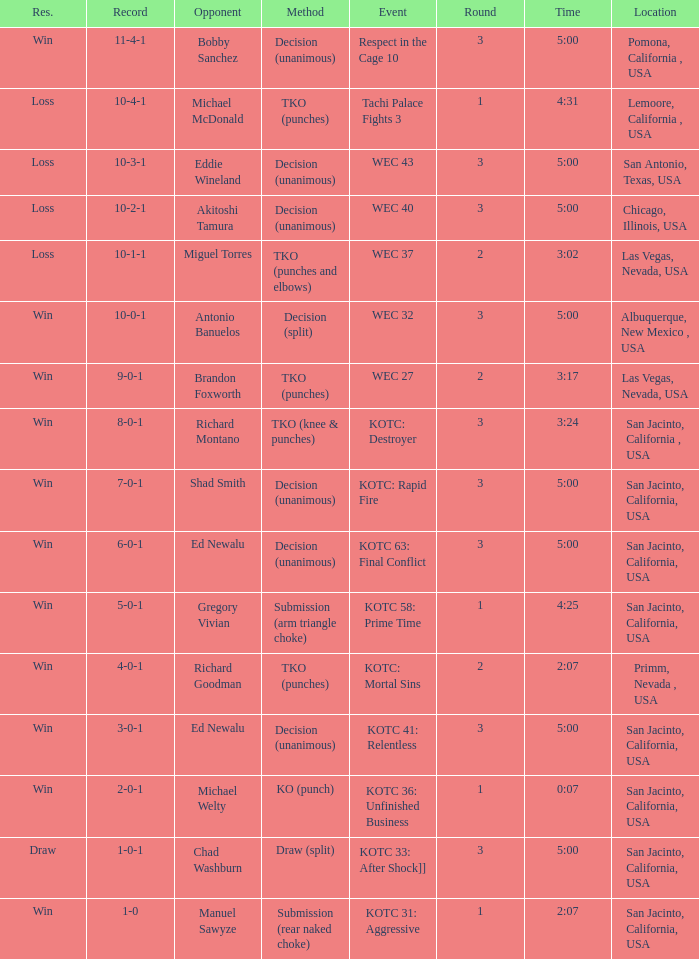What location did the event kotc: mortal sins take place? Primm, Nevada , USA. 